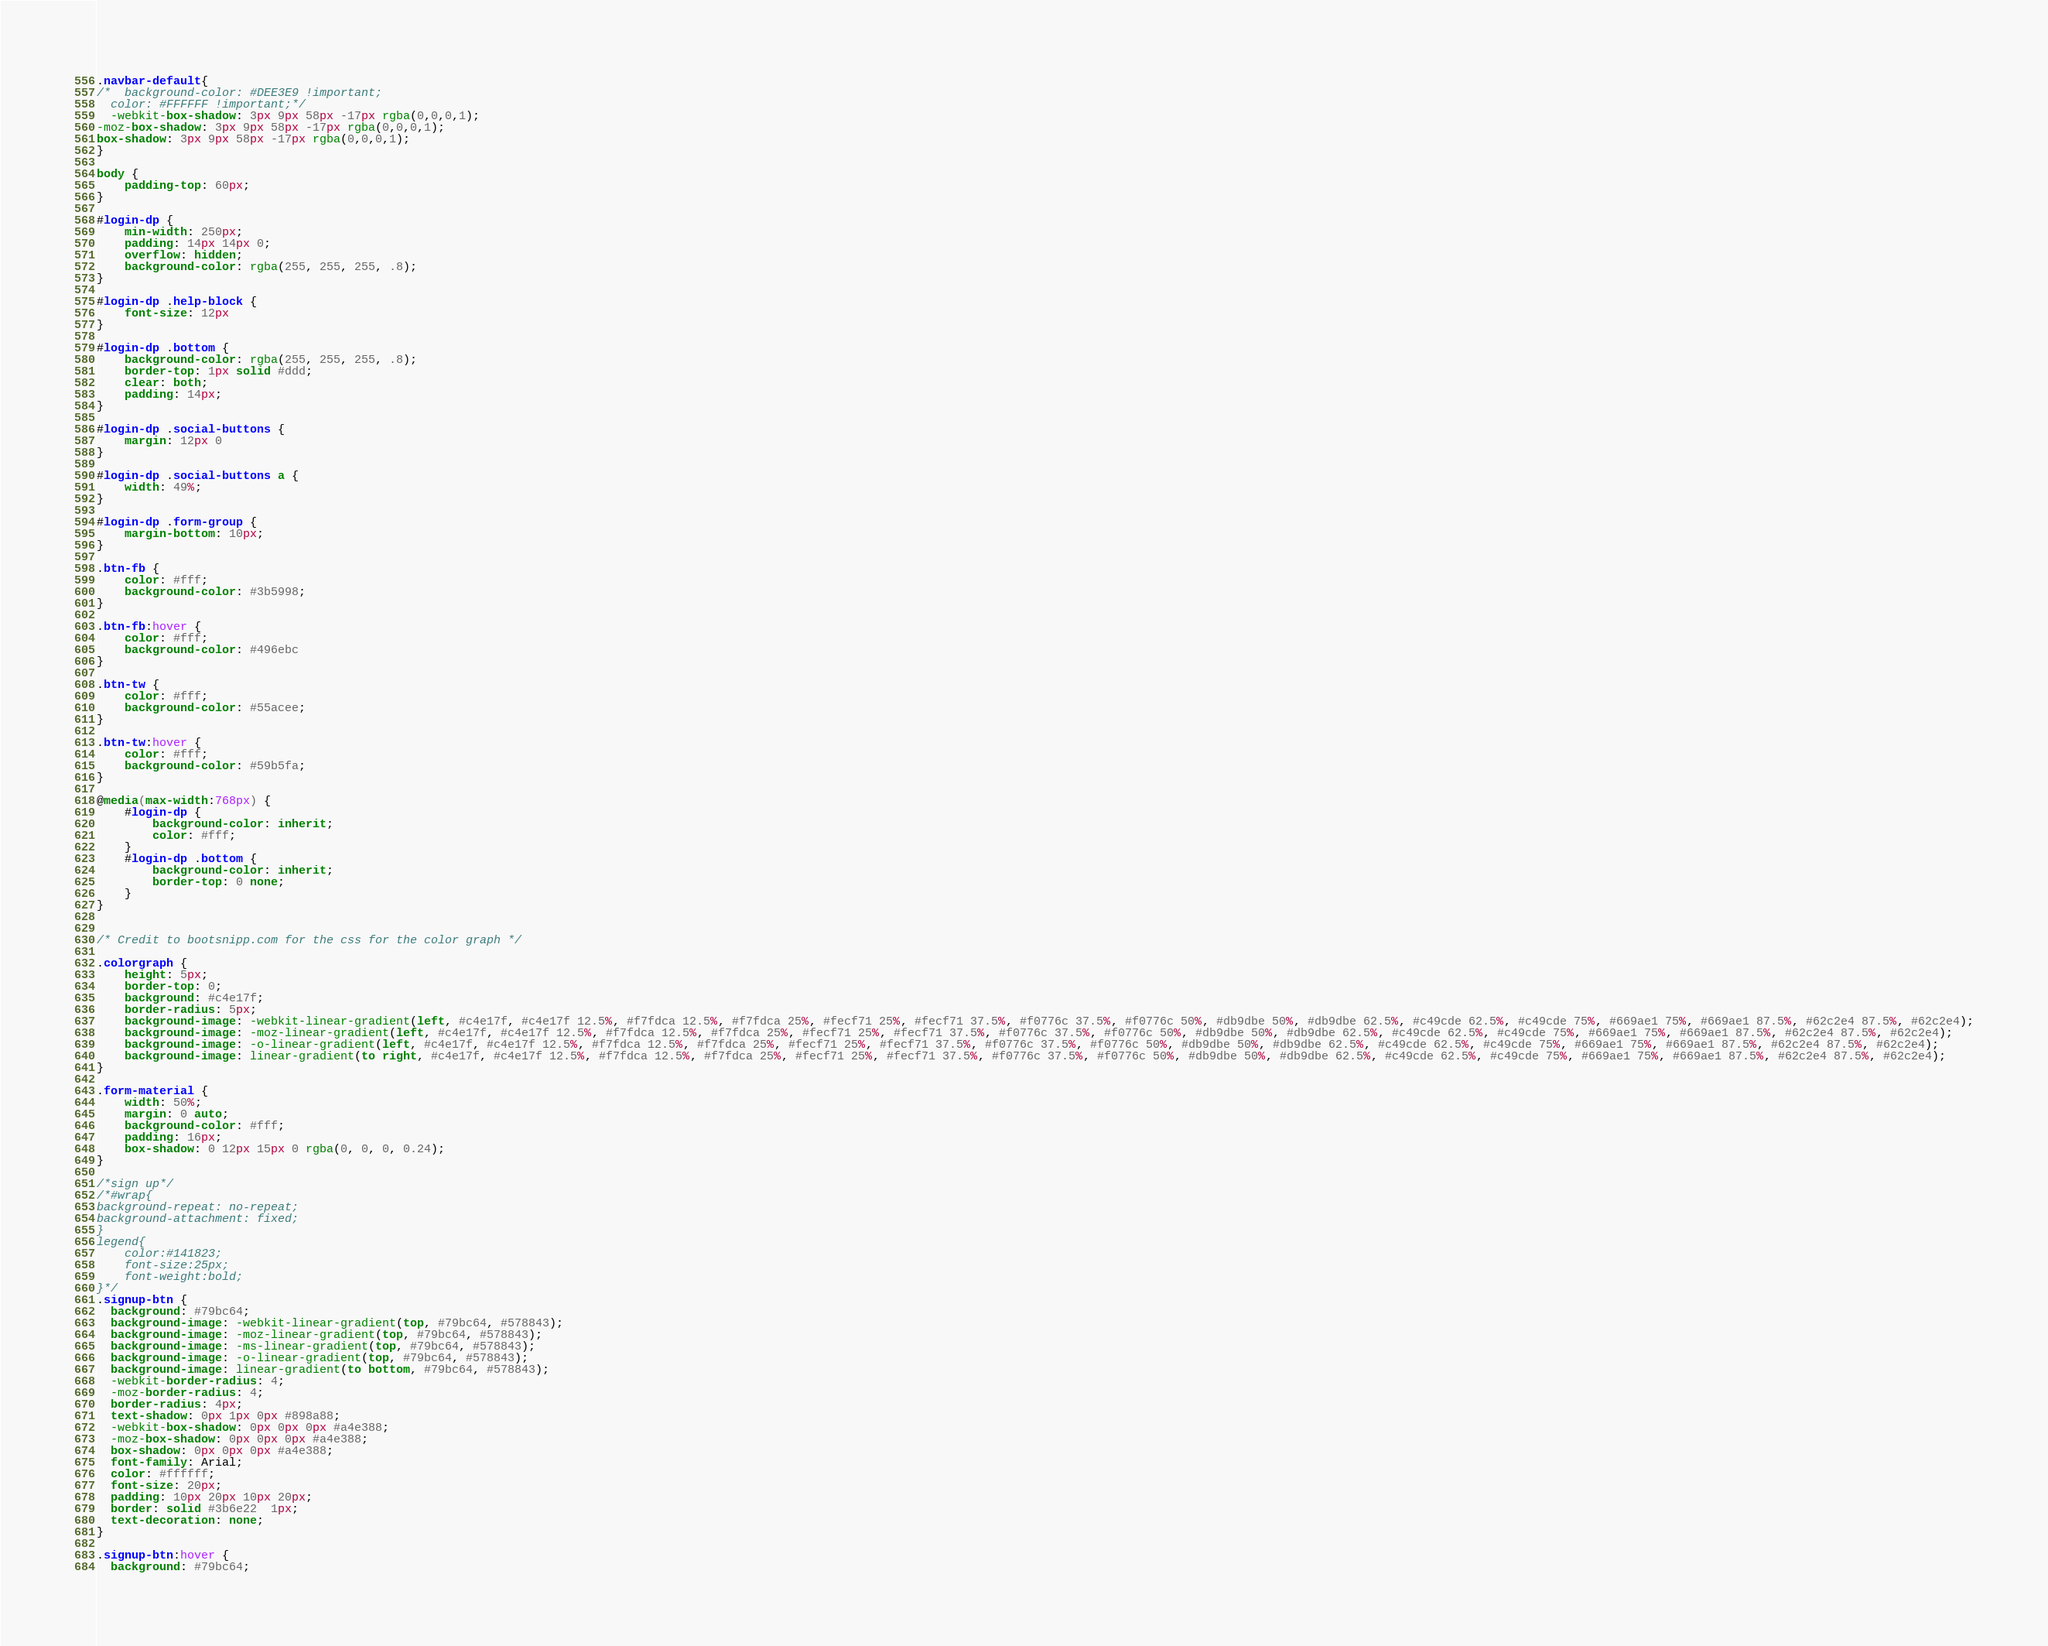Convert code to text. <code><loc_0><loc_0><loc_500><loc_500><_CSS_>.navbar-default{
/*  background-color: #DEE3E9 !important;
  color: #FFFFFF !important;*/
  -webkit-box-shadow: 3px 9px 58px -17px rgba(0,0,0,1);
-moz-box-shadow: 3px 9px 58px -17px rgba(0,0,0,1);
box-shadow: 3px 9px 58px -17px rgba(0,0,0,1);
}

body {
    padding-top: 60px;
}

#login-dp {
    min-width: 250px;
    padding: 14px 14px 0;
    overflow: hidden;
    background-color: rgba(255, 255, 255, .8);
}

#login-dp .help-block {
    font-size: 12px
}

#login-dp .bottom {
    background-color: rgba(255, 255, 255, .8);
    border-top: 1px solid #ddd;
    clear: both;
    padding: 14px;
}

#login-dp .social-buttons {
    margin: 12px 0
}

#login-dp .social-buttons a {
    width: 49%;
}

#login-dp .form-group {
    margin-bottom: 10px;
}

.btn-fb {
    color: #fff;
    background-color: #3b5998;
}

.btn-fb:hover {
    color: #fff;
    background-color: #496ebc
}

.btn-tw {
    color: #fff;
    background-color: #55acee;
}

.btn-tw:hover {
    color: #fff;
    background-color: #59b5fa;
}

@media(max-width:768px) {
    #login-dp {
        background-color: inherit;
        color: #fff;
    }
    #login-dp .bottom {
        background-color: inherit;
        border-top: 0 none;
    }
}


/* Credit to bootsnipp.com for the css for the color graph */

.colorgraph {
    height: 5px;
    border-top: 0;
    background: #c4e17f;
    border-radius: 5px;
    background-image: -webkit-linear-gradient(left, #c4e17f, #c4e17f 12.5%, #f7fdca 12.5%, #f7fdca 25%, #fecf71 25%, #fecf71 37.5%, #f0776c 37.5%, #f0776c 50%, #db9dbe 50%, #db9dbe 62.5%, #c49cde 62.5%, #c49cde 75%, #669ae1 75%, #669ae1 87.5%, #62c2e4 87.5%, #62c2e4);
    background-image: -moz-linear-gradient(left, #c4e17f, #c4e17f 12.5%, #f7fdca 12.5%, #f7fdca 25%, #fecf71 25%, #fecf71 37.5%, #f0776c 37.5%, #f0776c 50%, #db9dbe 50%, #db9dbe 62.5%, #c49cde 62.5%, #c49cde 75%, #669ae1 75%, #669ae1 87.5%, #62c2e4 87.5%, #62c2e4);
    background-image: -o-linear-gradient(left, #c4e17f, #c4e17f 12.5%, #f7fdca 12.5%, #f7fdca 25%, #fecf71 25%, #fecf71 37.5%, #f0776c 37.5%, #f0776c 50%, #db9dbe 50%, #db9dbe 62.5%, #c49cde 62.5%, #c49cde 75%, #669ae1 75%, #669ae1 87.5%, #62c2e4 87.5%, #62c2e4);
    background-image: linear-gradient(to right, #c4e17f, #c4e17f 12.5%, #f7fdca 12.5%, #f7fdca 25%, #fecf71 25%, #fecf71 37.5%, #f0776c 37.5%, #f0776c 50%, #db9dbe 50%, #db9dbe 62.5%, #c49cde 62.5%, #c49cde 75%, #669ae1 75%, #669ae1 87.5%, #62c2e4 87.5%, #62c2e4);
}

.form-material {
    width: 50%;
    margin: 0 auto;
    background-color: #fff;
    padding: 16px;
    box-shadow: 0 12px 15px 0 rgba(0, 0, 0, 0.24);
}

/*sign up*/
/*#wrap{
background-repeat: no-repeat;
background-attachment: fixed;
}
legend{
    color:#141823;
    font-size:25px;
    font-weight:bold;
}*/
.signup-btn {
  background: #79bc64;
  background-image: -webkit-linear-gradient(top, #79bc64, #578843);
  background-image: -moz-linear-gradient(top, #79bc64, #578843);
  background-image: -ms-linear-gradient(top, #79bc64, #578843);
  background-image: -o-linear-gradient(top, #79bc64, #578843);
  background-image: linear-gradient(to bottom, #79bc64, #578843);
  -webkit-border-radius: 4;
  -moz-border-radius: 4;
  border-radius: 4px;
  text-shadow: 0px 1px 0px #898a88;
  -webkit-box-shadow: 0px 0px 0px #a4e388;
  -moz-box-shadow: 0px 0px 0px #a4e388;
  box-shadow: 0px 0px 0px #a4e388;
  font-family: Arial;
  color: #ffffff;
  font-size: 20px;
  padding: 10px 20px 10px 20px;
  border: solid #3b6e22  1px;
  text-decoration: none;
}

.signup-btn:hover {
  background: #79bc64;</code> 